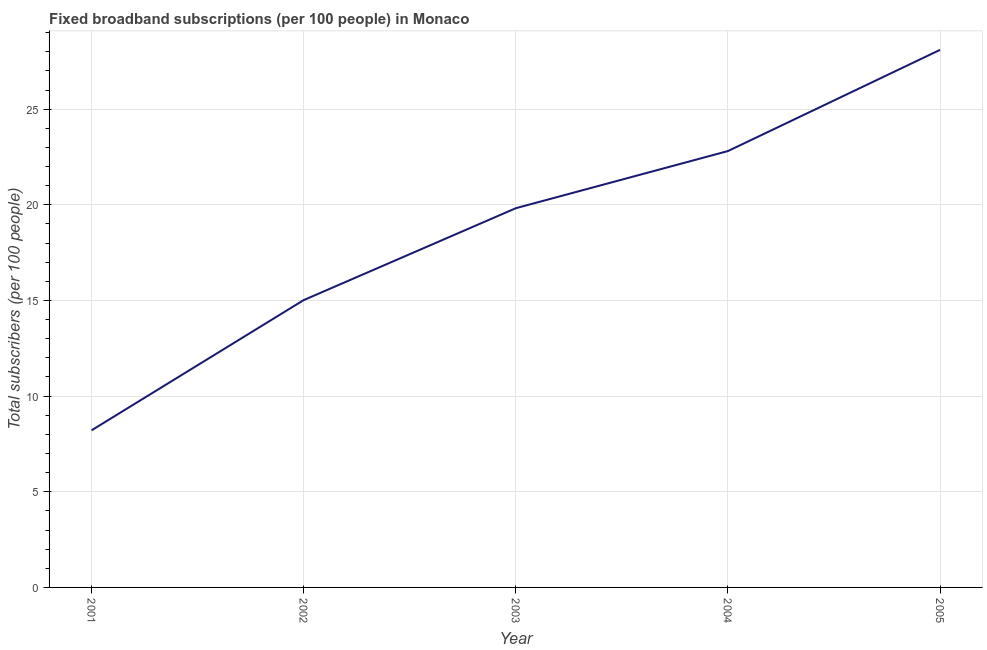What is the total number of fixed broadband subscriptions in 2003?
Keep it short and to the point. 19.82. Across all years, what is the maximum total number of fixed broadband subscriptions?
Provide a short and direct response. 28.1. Across all years, what is the minimum total number of fixed broadband subscriptions?
Offer a terse response. 8.21. In which year was the total number of fixed broadband subscriptions maximum?
Provide a succinct answer. 2005. What is the sum of the total number of fixed broadband subscriptions?
Make the answer very short. 93.96. What is the difference between the total number of fixed broadband subscriptions in 2002 and 2004?
Keep it short and to the point. -7.79. What is the average total number of fixed broadband subscriptions per year?
Give a very brief answer. 18.79. What is the median total number of fixed broadband subscriptions?
Keep it short and to the point. 19.82. In how many years, is the total number of fixed broadband subscriptions greater than 9 ?
Your answer should be compact. 4. What is the ratio of the total number of fixed broadband subscriptions in 2002 to that in 2003?
Your answer should be compact. 0.76. Is the difference between the total number of fixed broadband subscriptions in 2001 and 2002 greater than the difference between any two years?
Ensure brevity in your answer.  No. What is the difference between the highest and the second highest total number of fixed broadband subscriptions?
Give a very brief answer. 5.29. Is the sum of the total number of fixed broadband subscriptions in 2001 and 2005 greater than the maximum total number of fixed broadband subscriptions across all years?
Keep it short and to the point. Yes. What is the difference between the highest and the lowest total number of fixed broadband subscriptions?
Keep it short and to the point. 19.89. In how many years, is the total number of fixed broadband subscriptions greater than the average total number of fixed broadband subscriptions taken over all years?
Your answer should be very brief. 3. How many lines are there?
Provide a short and direct response. 1. What is the difference between two consecutive major ticks on the Y-axis?
Keep it short and to the point. 5. What is the title of the graph?
Keep it short and to the point. Fixed broadband subscriptions (per 100 people) in Monaco. What is the label or title of the X-axis?
Offer a very short reply. Year. What is the label or title of the Y-axis?
Your response must be concise. Total subscribers (per 100 people). What is the Total subscribers (per 100 people) in 2001?
Ensure brevity in your answer.  8.21. What is the Total subscribers (per 100 people) in 2002?
Your answer should be very brief. 15.02. What is the Total subscribers (per 100 people) of 2003?
Make the answer very short. 19.82. What is the Total subscribers (per 100 people) of 2004?
Your response must be concise. 22.81. What is the Total subscribers (per 100 people) of 2005?
Give a very brief answer. 28.1. What is the difference between the Total subscribers (per 100 people) in 2001 and 2002?
Make the answer very short. -6.81. What is the difference between the Total subscribers (per 100 people) in 2001 and 2003?
Make the answer very short. -11.61. What is the difference between the Total subscribers (per 100 people) in 2001 and 2004?
Your answer should be compact. -14.6. What is the difference between the Total subscribers (per 100 people) in 2001 and 2005?
Your response must be concise. -19.89. What is the difference between the Total subscribers (per 100 people) in 2002 and 2003?
Offer a terse response. -4.8. What is the difference between the Total subscribers (per 100 people) in 2002 and 2004?
Provide a short and direct response. -7.79. What is the difference between the Total subscribers (per 100 people) in 2002 and 2005?
Your answer should be compact. -13.08. What is the difference between the Total subscribers (per 100 people) in 2003 and 2004?
Make the answer very short. -2.99. What is the difference between the Total subscribers (per 100 people) in 2003 and 2005?
Keep it short and to the point. -8.28. What is the difference between the Total subscribers (per 100 people) in 2004 and 2005?
Ensure brevity in your answer.  -5.29. What is the ratio of the Total subscribers (per 100 people) in 2001 to that in 2002?
Offer a terse response. 0.55. What is the ratio of the Total subscribers (per 100 people) in 2001 to that in 2003?
Provide a short and direct response. 0.41. What is the ratio of the Total subscribers (per 100 people) in 2001 to that in 2004?
Make the answer very short. 0.36. What is the ratio of the Total subscribers (per 100 people) in 2001 to that in 2005?
Your answer should be very brief. 0.29. What is the ratio of the Total subscribers (per 100 people) in 2002 to that in 2003?
Provide a short and direct response. 0.76. What is the ratio of the Total subscribers (per 100 people) in 2002 to that in 2004?
Your answer should be very brief. 0.66. What is the ratio of the Total subscribers (per 100 people) in 2002 to that in 2005?
Provide a succinct answer. 0.53. What is the ratio of the Total subscribers (per 100 people) in 2003 to that in 2004?
Ensure brevity in your answer.  0.87. What is the ratio of the Total subscribers (per 100 people) in 2003 to that in 2005?
Your answer should be compact. 0.7. What is the ratio of the Total subscribers (per 100 people) in 2004 to that in 2005?
Offer a very short reply. 0.81. 